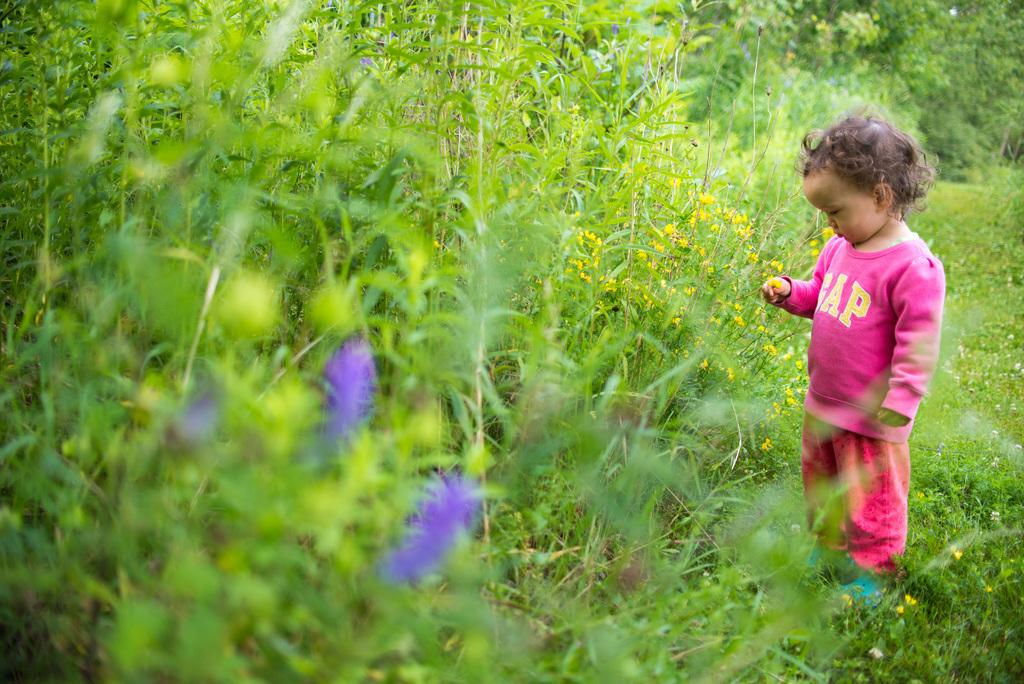What is the main subject of the image? The main subject of the image is a kid standing on the ground. What can be seen in the background of the image? In the background, there are plants with flowers and trees. What type of cherry is the kid holding in the image? There is no cherry present in the image; the main subject is a kid standing on the ground. What kind of thing is the kid wearing on their foot? There is no information about the kid's footwear in the image, so it cannot be determined from the image. 